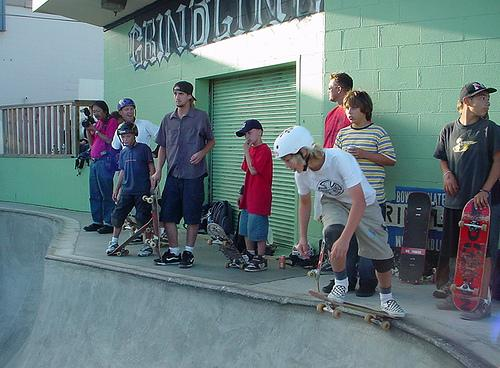What type of skate maneuver is the boy in white about to perform? Please explain your reasoning. drop in. Going from a platform into a steep transition is called dropping in. 